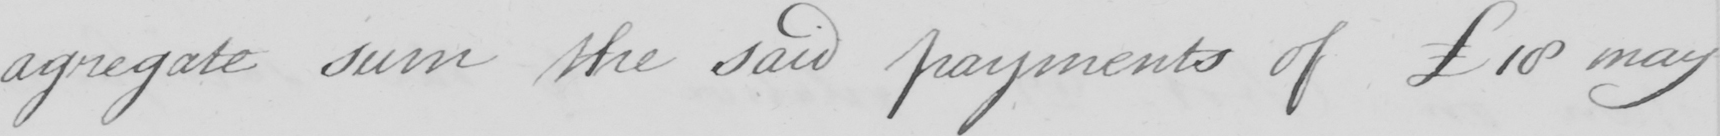What is written in this line of handwriting? agregate sum the said payments of £18 may 